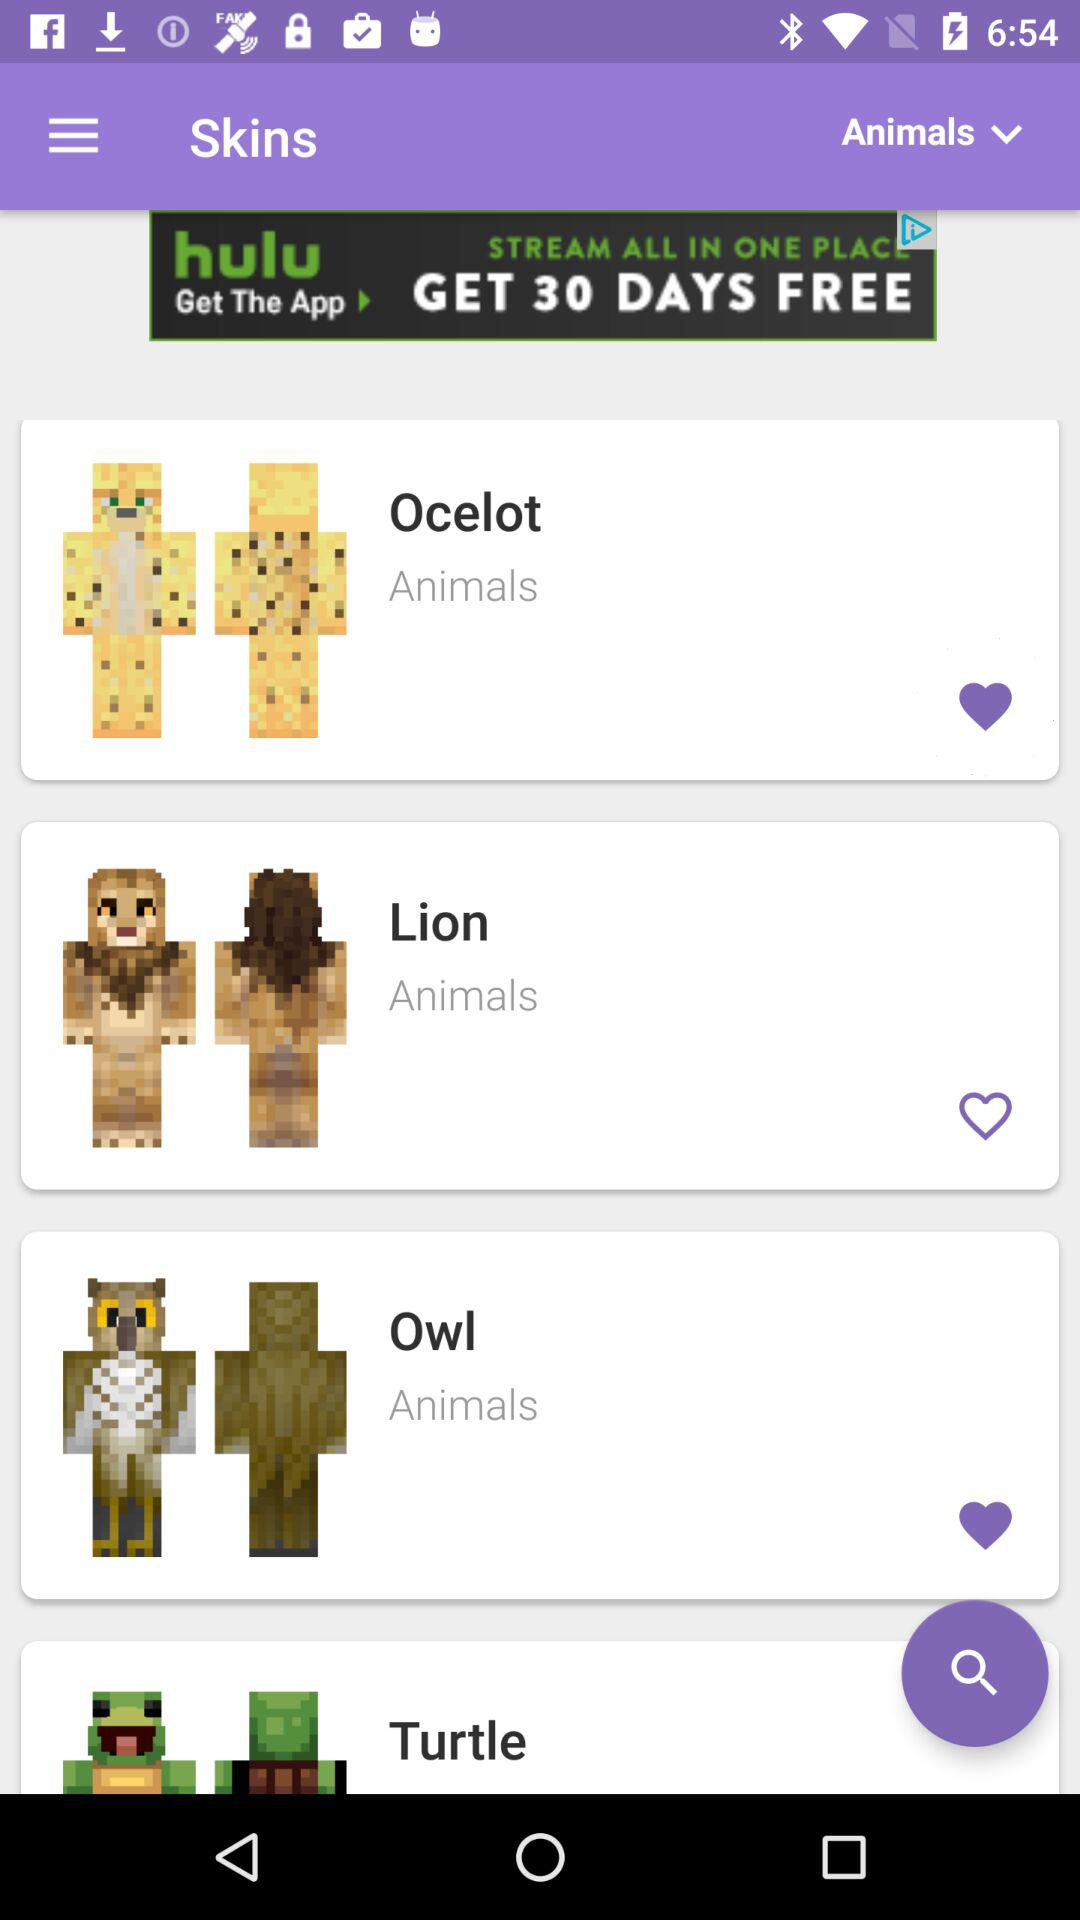Which animal skins are marked as favorites? The animal skins that are marked as favorites are "Ocelot" and "Owl". 